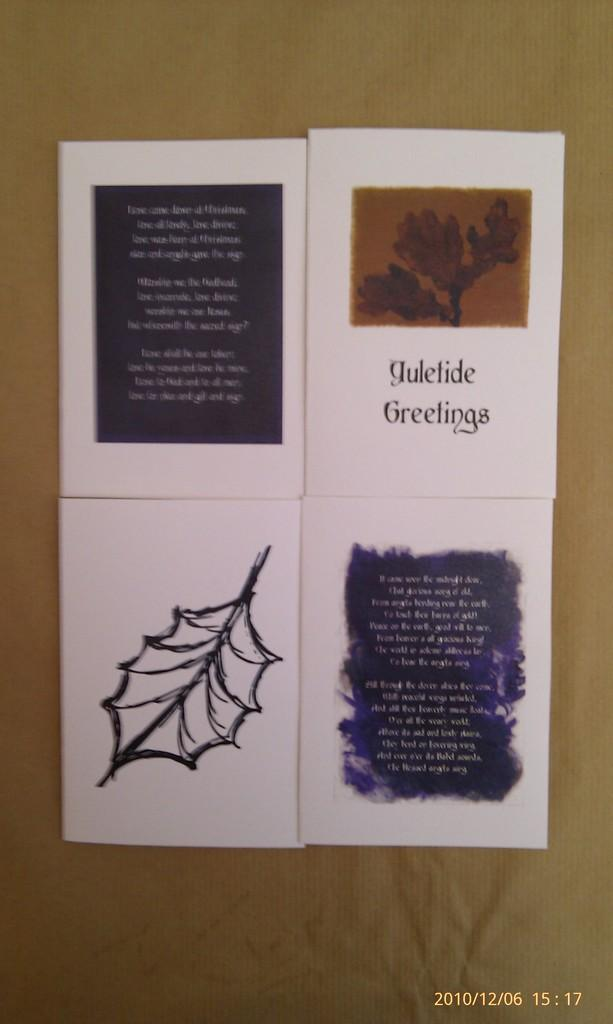<image>
Create a compact narrative representing the image presented. A card that says yuletide greetings sits near a drawing of a leaf in black and white. 